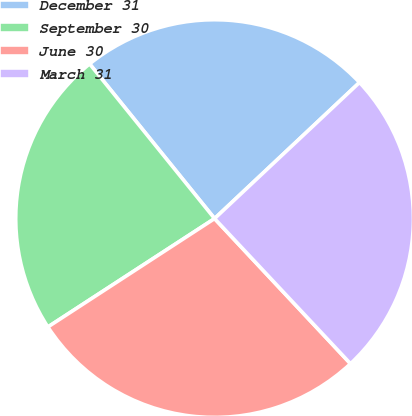Convert chart. <chart><loc_0><loc_0><loc_500><loc_500><pie_chart><fcel>December 31<fcel>September 30<fcel>June 30<fcel>March 31<nl><fcel>23.81%<fcel>23.36%<fcel>27.8%<fcel>25.02%<nl></chart> 